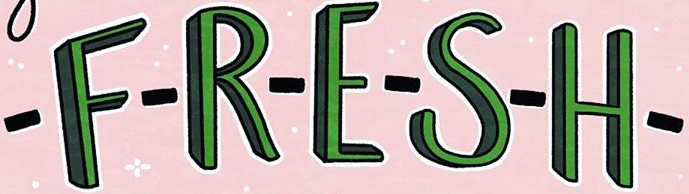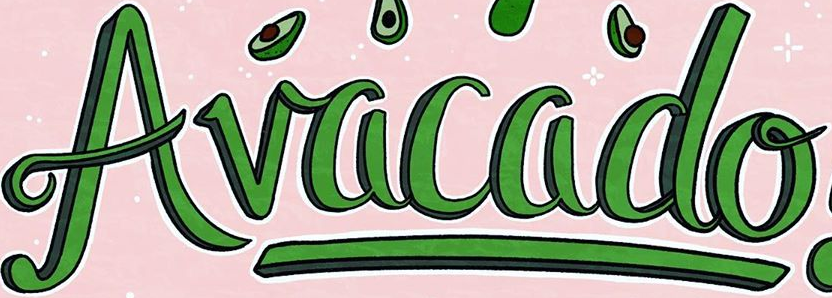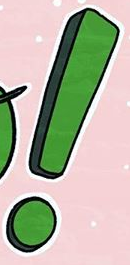Read the text content from these images in order, separated by a semicolon. -F-R-E-S-H-; Avacado; ! 